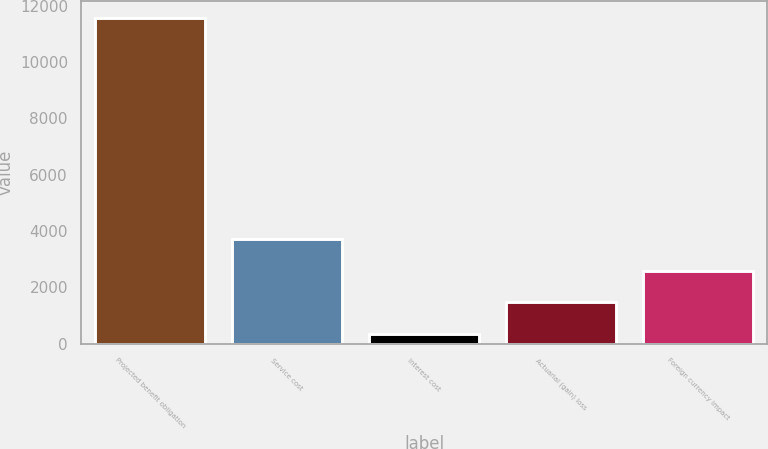<chart> <loc_0><loc_0><loc_500><loc_500><bar_chart><fcel>Projected benefit obligation<fcel>Service cost<fcel>Interest cost<fcel>Actuarial (gain) loss<fcel>Foreign currency impact<nl><fcel>11569<fcel>3717.8<fcel>353<fcel>1474.6<fcel>2596.2<nl></chart> 